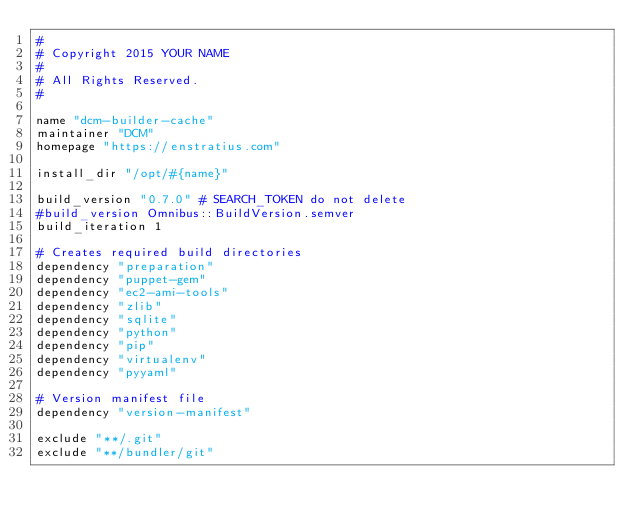Convert code to text. <code><loc_0><loc_0><loc_500><loc_500><_Ruby_>#
# Copyright 2015 YOUR NAME
#
# All Rights Reserved.
#

name "dcm-builder-cache"
maintainer "DCM"
homepage "https://enstratius.com"

install_dir "/opt/#{name}"

build_version "0.7.0" # SEARCH_TOKEN do not delete
#build_version Omnibus::BuildVersion.semver
build_iteration 1

# Creates required build directories
dependency "preparation"
dependency "puppet-gem"
dependency "ec2-ami-tools"
dependency "zlib"
dependency "sqlite"
dependency "python"
dependency "pip"
dependency "virtualenv"
dependency "pyyaml"

# Version manifest file
dependency "version-manifest"

exclude "**/.git"
exclude "**/bundler/git"
</code> 